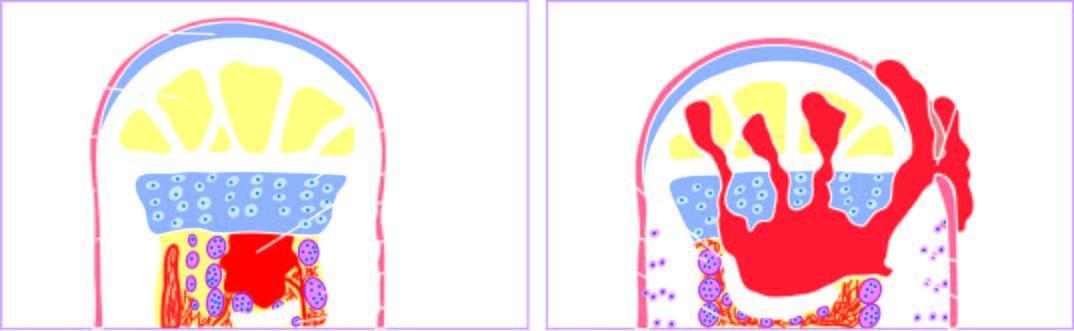what does process begin as?
Answer the question using a single word or phrase. A focus of microabscess in a vascular loop in the marrow which expands to stimulate 